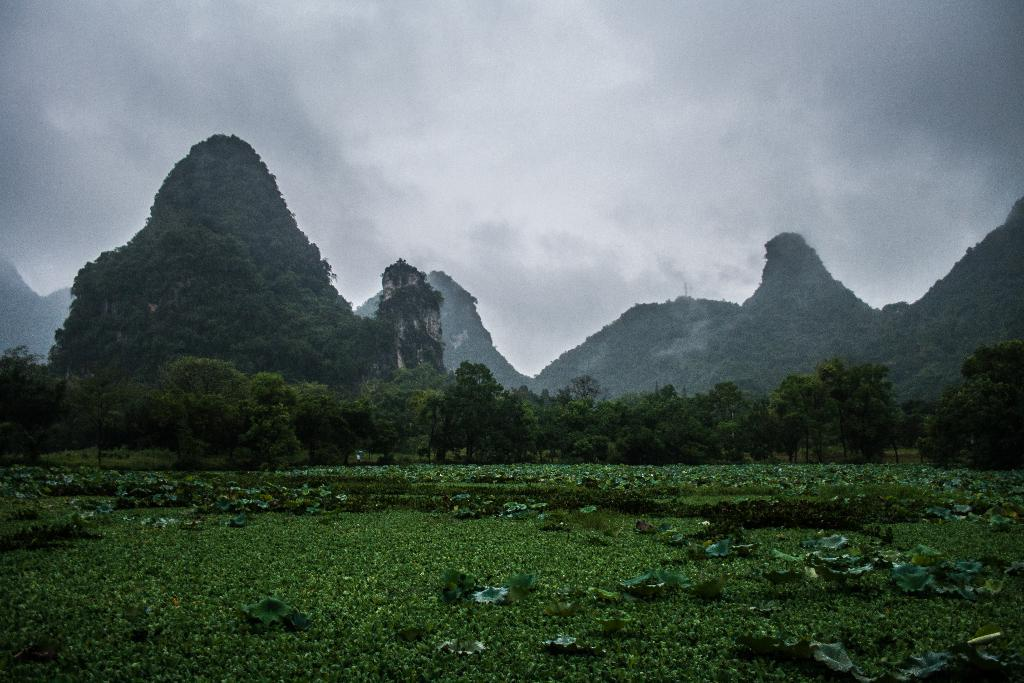What type of vegetation can be seen in the image? There is a group of plants and a group of trees visible in the image. What specific part of the plants can be seen in the image? Leaves are visible in the image. What type of landscape feature is visible in the image? The mountains are visible in the image. How would you describe the weather in the image? The sky is cloudy in the image. How many ants can be seen carrying a coil in the image? There are no ants or coils present in the image. What type of friction is occurring between the plants and the ground in the image? There is no information about friction between the plants and the ground in the image. 